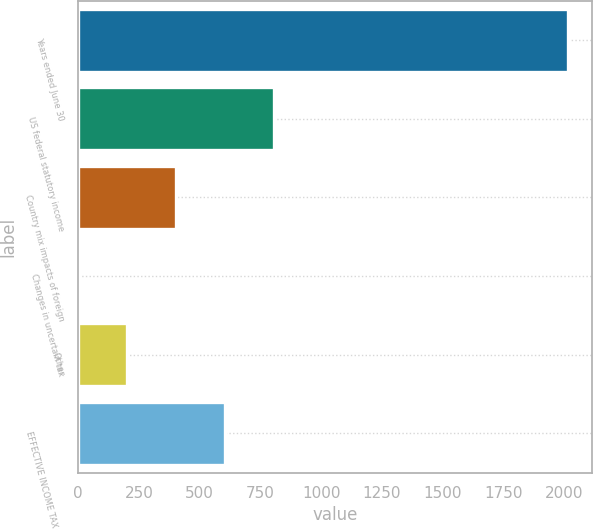Convert chart to OTSL. <chart><loc_0><loc_0><loc_500><loc_500><bar_chart><fcel>Years ended June 30<fcel>US federal statutory income<fcel>Country mix impacts of foreign<fcel>Changes in uncertain tax<fcel>Other<fcel>EFFECTIVE INCOME TAX RATE<nl><fcel>2015<fcel>806.54<fcel>403.72<fcel>0.9<fcel>202.31<fcel>605.13<nl></chart> 